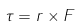Convert formula to latex. <formula><loc_0><loc_0><loc_500><loc_500>\tau = r \times F</formula> 